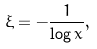Convert formula to latex. <formula><loc_0><loc_0><loc_500><loc_500>\xi = - \frac { 1 } { \log { x } } ,</formula> 